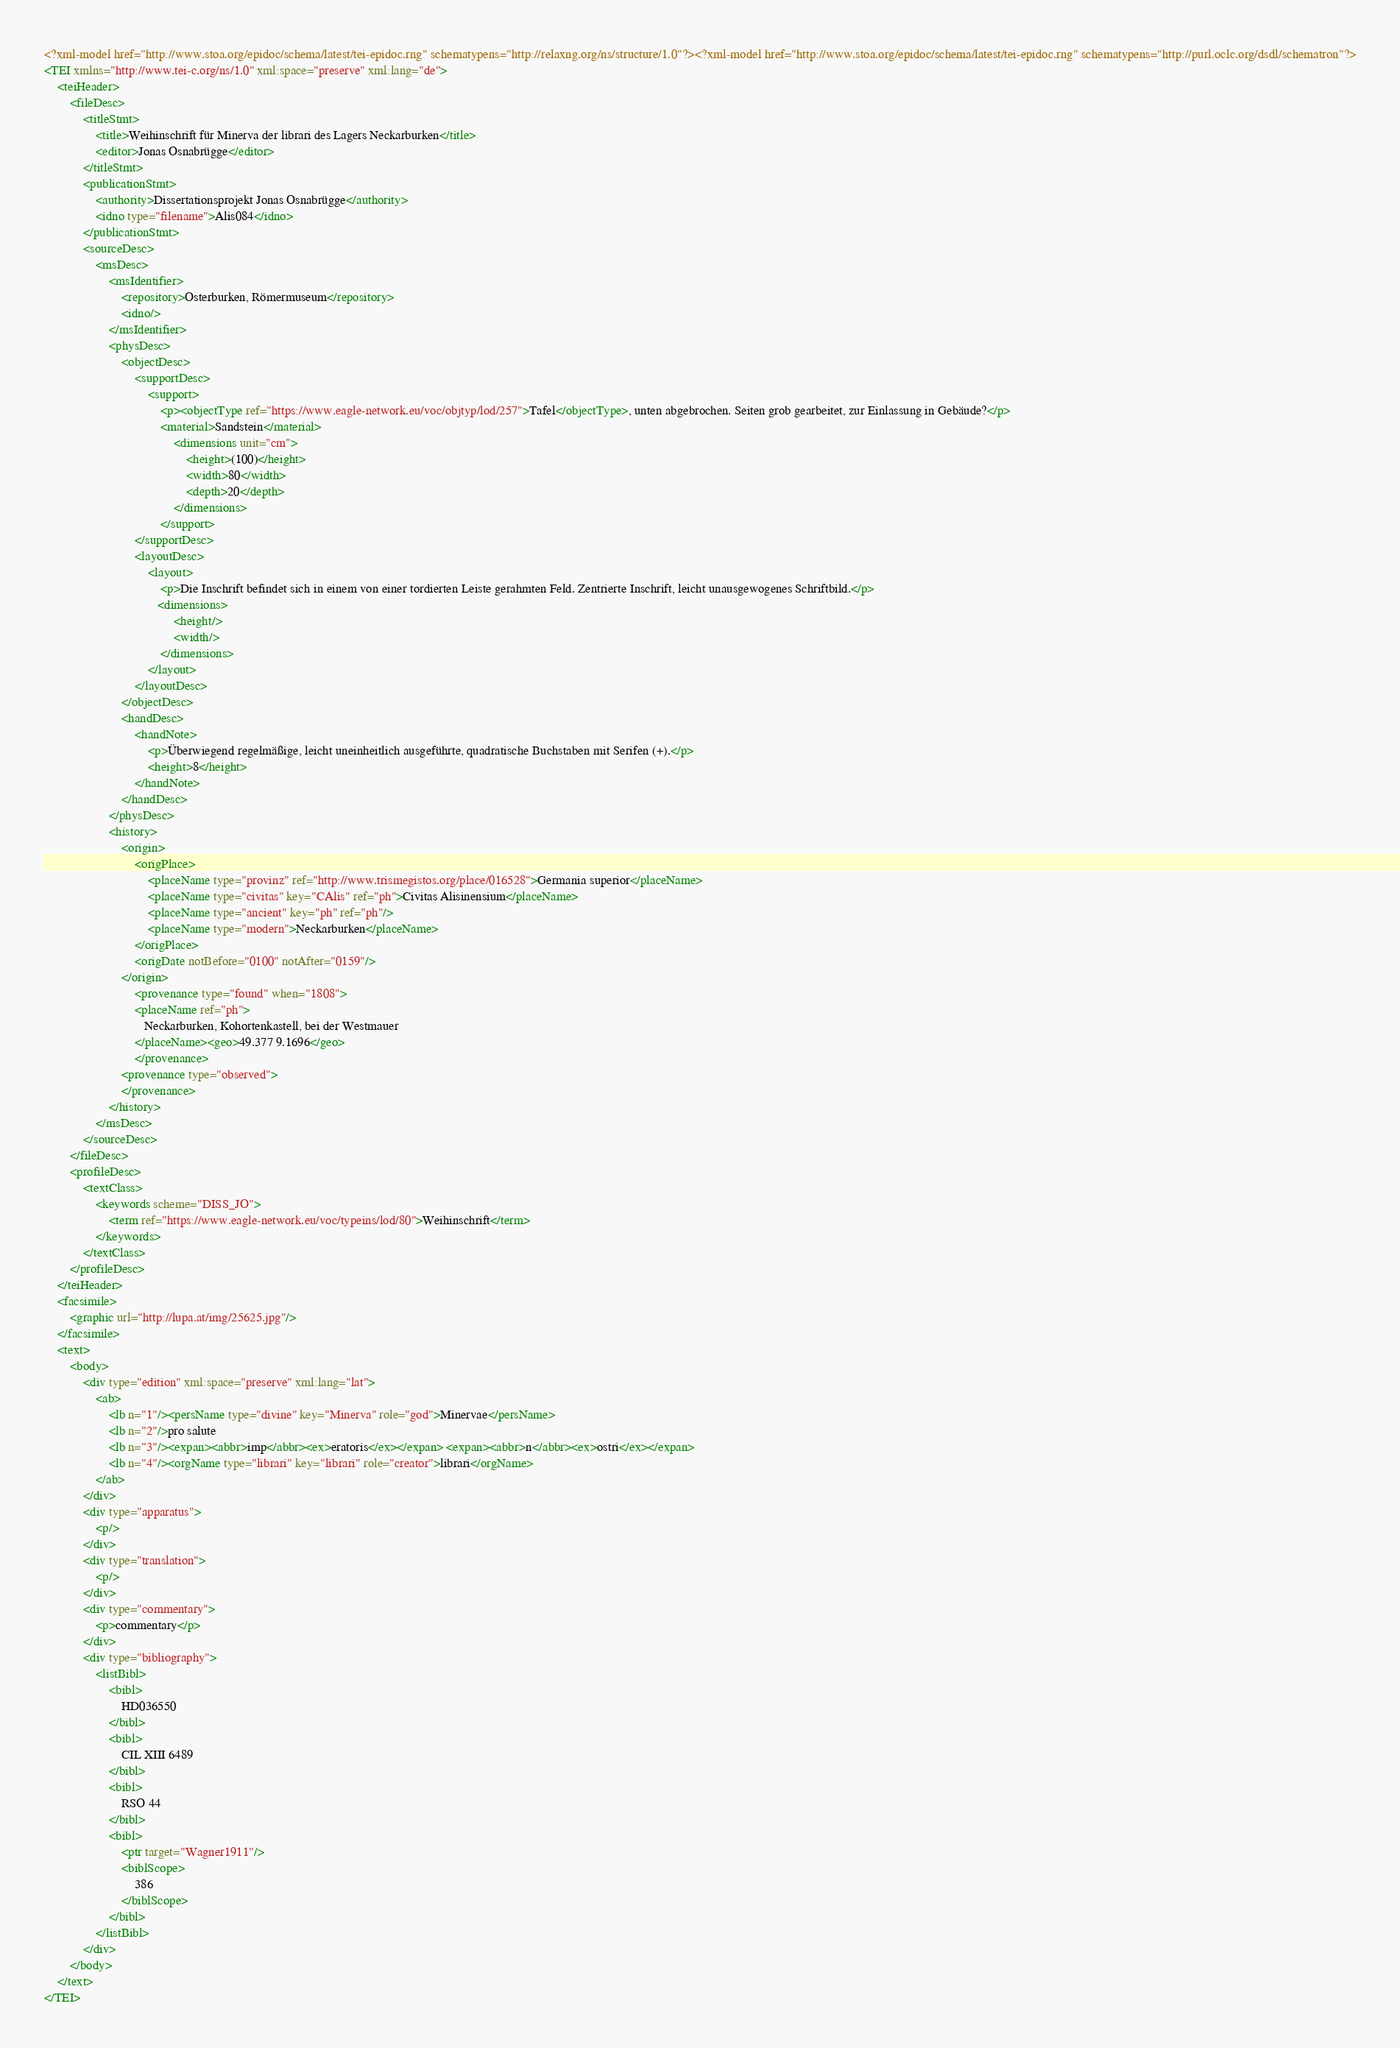Convert code to text. <code><loc_0><loc_0><loc_500><loc_500><_XML_><?xml-model href="http://www.stoa.org/epidoc/schema/latest/tei-epidoc.rng" schematypens="http://relaxng.org/ns/structure/1.0"?><?xml-model href="http://www.stoa.org/epidoc/schema/latest/tei-epidoc.rng" schematypens="http://purl.oclc.org/dsdl/schematron"?>
<TEI xmlns="http://www.tei-c.org/ns/1.0" xml:space="preserve" xml:lang="de">
    <teiHeader>
        <fileDesc>
            <titleStmt>
                <title>Weihinschrift für Minerva der librari des Lagers Neckarburken</title>
                <editor>Jonas Osnabrügge</editor>
            </titleStmt>
            <publicationStmt>
                <authority>Dissertationsprojekt Jonas Osnabrügge</authority>
                <idno type="filename">Alis084</idno>
            </publicationStmt>
            <sourceDesc>
                <msDesc>
                    <msIdentifier>
                        <repository>Osterburken, Römermuseum</repository>
                        <idno/>
                    </msIdentifier>
                    <physDesc>
                        <objectDesc>
                            <supportDesc>
                                <support>
                                    <p><objectType ref="https://www.eagle-network.eu/voc/objtyp/lod/257">Tafel</objectType>, unten abgebrochen. Seiten grob gearbeitet, zur Einlassung in Gebäude?</p>
                                    <material>Sandstein</material>
                                        <dimensions unit="cm">
                                            <height>(100)</height>
                                            <width>80</width>
                                            <depth>20</depth>
                                        </dimensions>
                                    </support>
                            </supportDesc>
                            <layoutDesc>
                                <layout>
                                    <p>Die Inschrift befindet sich in einem von einer tordierten Leiste gerahmten Feld. Zentrierte Inschrift, leicht unausgewogenes Schriftbild.</p>
                                   <dimensions>
                                        <height/>
                                        <width/>
                                    </dimensions>
                                </layout>
                            </layoutDesc>
                        </objectDesc>
                        <handDesc>
                            <handNote>
                                <p>Überwiegend regelmäßige, leicht uneinheitlich ausgeführte, quadratische Buchstaben mit Serifen (+).</p>
                                <height>8</height>
                            </handNote>
                        </handDesc>
                    </physDesc>
                    <history>
                        <origin>
                            <origPlace>
                                <placeName type="provinz" ref="http://www.trismegistos.org/place/016528">Germania superior</placeName>
                                <placeName type="civitas" key="CAlis" ref="ph">Civitas Alisinensium</placeName>
                                <placeName type="ancient" key="ph" ref="ph"/>
                                <placeName type="modern">Neckarburken</placeName> 
                            </origPlace>
                            <origDate notBefore="0100" notAfter="0159"/>
                        </origin>
                            <provenance type="found" when="1808">
                            <placeName ref="ph">
                               Neckarburken, Kohortenkastell, bei der Westmauer
                            </placeName><geo>49.377 9.1696</geo>
                            </provenance>
                        <provenance type="observed">
                        </provenance>
                    </history>
                </msDesc>
            </sourceDesc>
        </fileDesc>
        <profileDesc>
            <textClass>
                <keywords scheme="DISS_JO">
                    <term ref="https://www.eagle-network.eu/voc/typeins/lod/80">Weihinschrift</term>
                </keywords>
            </textClass>
        </profileDesc>
    </teiHeader>
    <facsimile>
        <graphic url="http://lupa.at/img/25625.jpg"/>
    </facsimile>
    <text>
        <body>
            <div type="edition" xml:space="preserve" xml:lang="lat">
                <ab>
                    <lb n="1"/><persName type="divine" key="Minerva" role="god">Minervae</persName>
                    <lb n="2"/>pro salute
                    <lb n="3"/><expan><abbr>imp</abbr><ex>eratoris</ex></expan> <expan><abbr>n</abbr><ex>ostri</ex></expan>
                    <lb n="4"/><orgName type="librari" key="librari" role="creator">librari</orgName>
                </ab>
            </div>
            <div type="apparatus">
                <p/>
            </div>
            <div type="translation">
                <p/>
            </div>
            <div type="commentary">
                <p>commentary</p>
            </div>
            <div type="bibliography">
                <listBibl>
                    <bibl>
                        HD036550
                    </bibl>
                    <bibl>
                        CIL XIII 6489
                    </bibl>
                    <bibl>
                        RSO 44
                    </bibl>
                    <bibl>
                        <ptr target="Wagner1911"/>
                        <biblScope>
                            386
                        </biblScope>
                    </bibl>
                </listBibl>
            </div>
        </body>
    </text>
</TEI></code> 